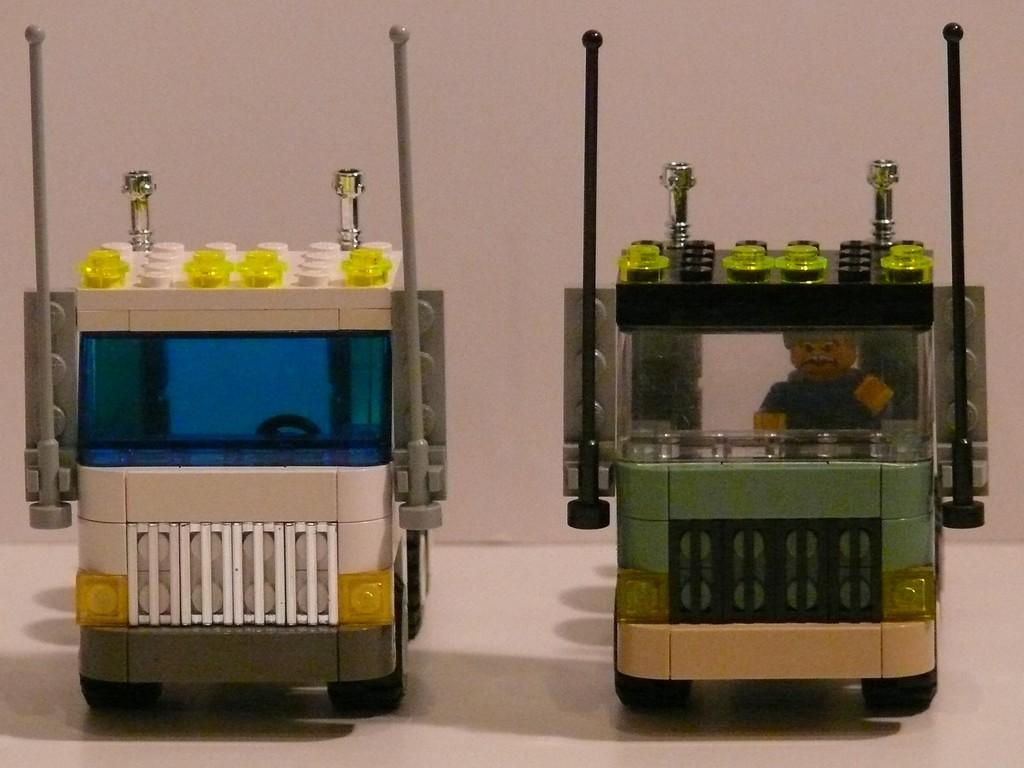What type of objects can be seen in the image? There are toys in the image. What part of the room is visible at the bottom of the image? The floor is visible at the bottom of the image. What can be seen in the background of the image? There is a wall in the background of the image. Is there a railway visible near the toys in the image? No, there is no railway present in the image. Can you see the sea in the background of the image? No, the sea is not visible in the image; there is only a wall in the background. 